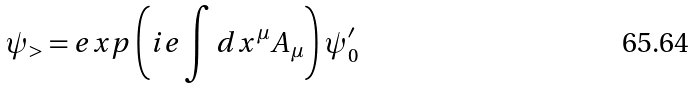Convert formula to latex. <formula><loc_0><loc_0><loc_500><loc_500>\psi _ { > } = e x p \left ( i e \int d x ^ { \mu } A _ { \mu } \right ) \psi _ { 0 } ^ { \prime }</formula> 